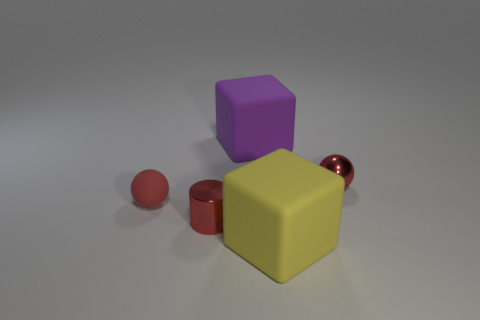Add 3 matte balls. How many objects exist? 8 Subtract all blocks. How many objects are left? 3 Subtract all small gray metallic blocks. Subtract all purple objects. How many objects are left? 4 Add 4 small shiny cylinders. How many small shiny cylinders are left? 5 Add 2 tiny cyan rubber spheres. How many tiny cyan rubber spheres exist? 2 Subtract 0 blue cylinders. How many objects are left? 5 